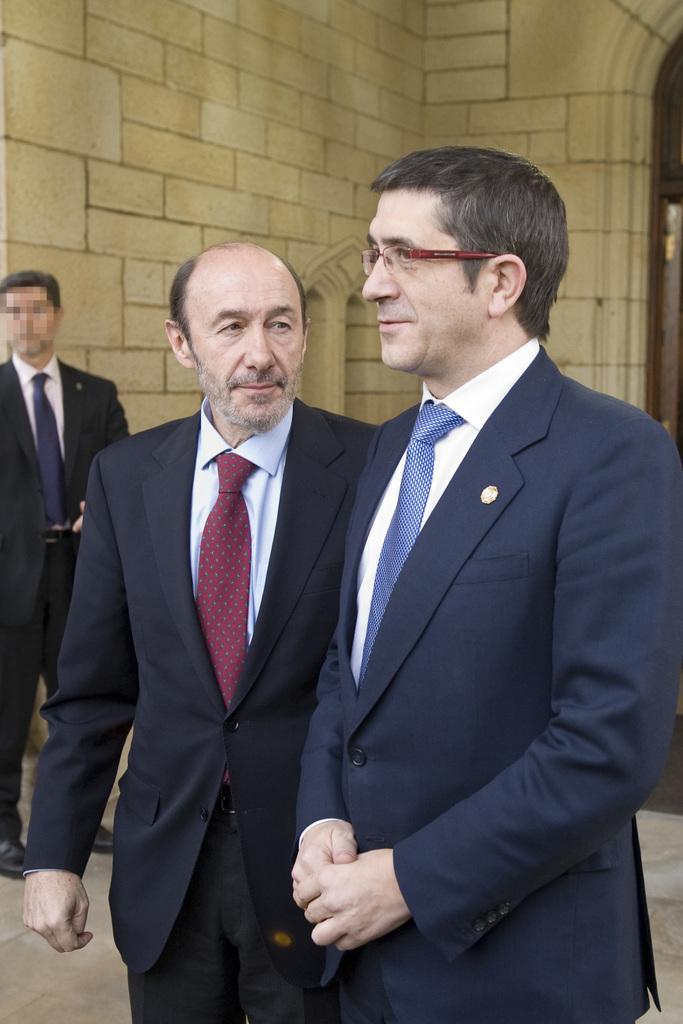Can you describe this image briefly? In this picture I can see there are two men standing and they are wearing blazers and the person at right has spectacles and there is another person standing at left and there is a wall in the background. 